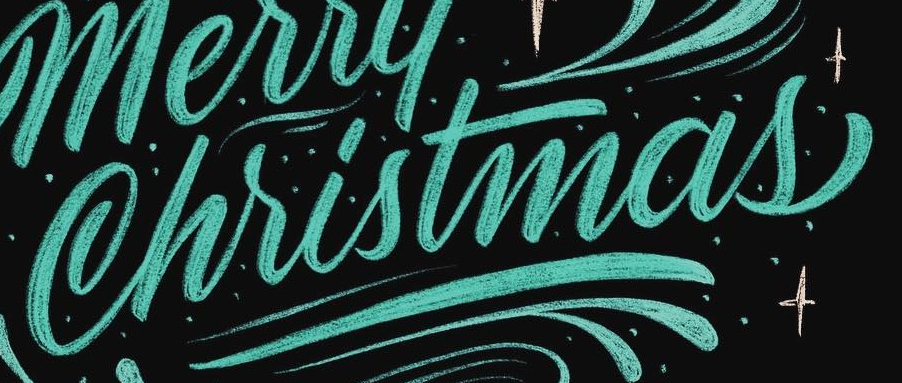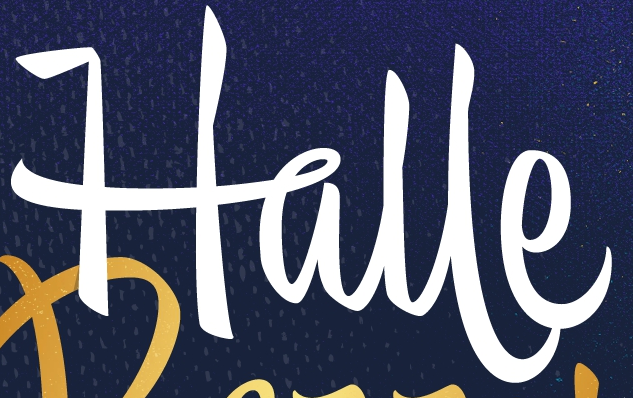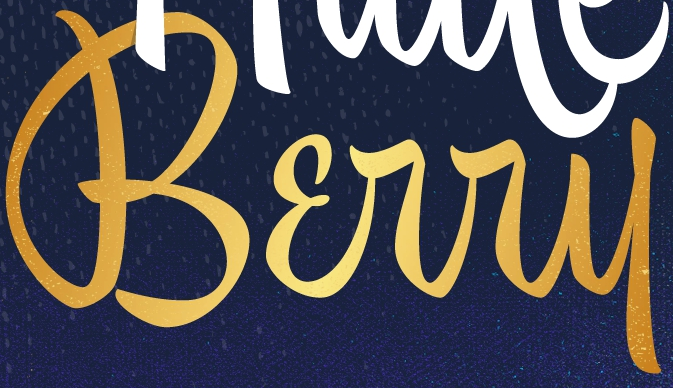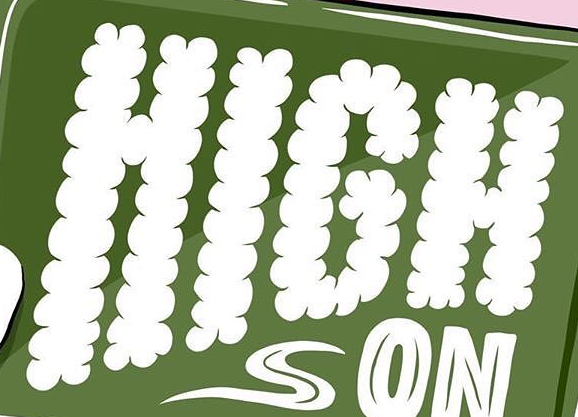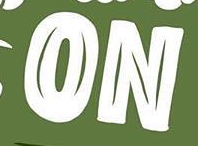Transcribe the words shown in these images in order, separated by a semicolon. Christmas; Halle; Bɛrry; HIGH; ON 